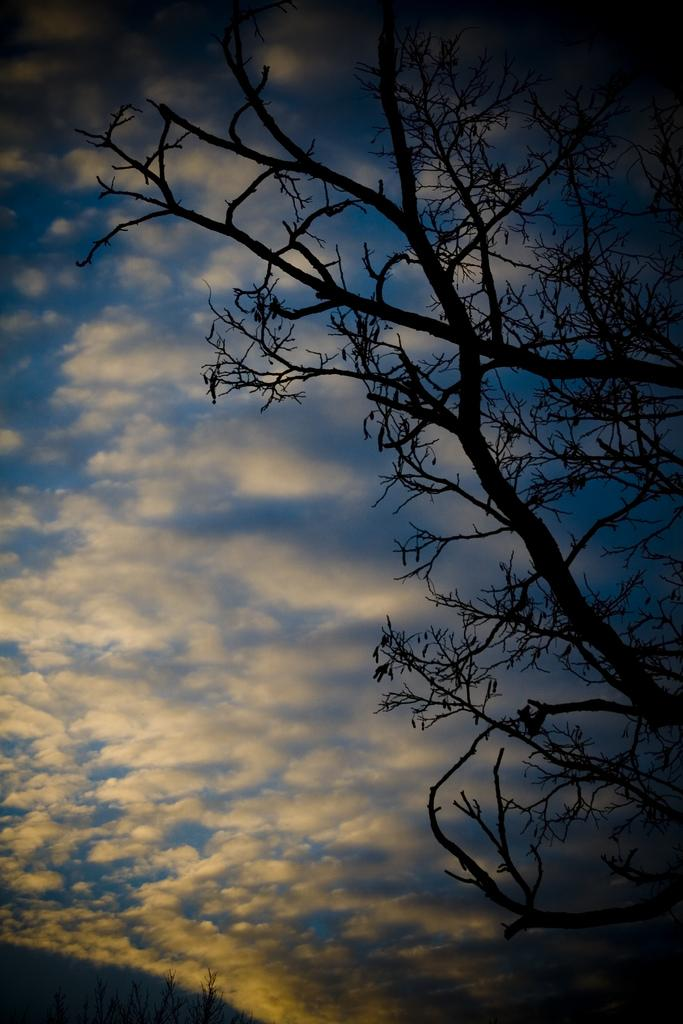What type of plant is visible in the image? There is a tree with branches and stems in the image. What can be seen in the sky in the image? There are clouds in the sky in the image. What type of band is playing music in the image? There is no band present in the image; it only features a tree and clouds in the sky. 